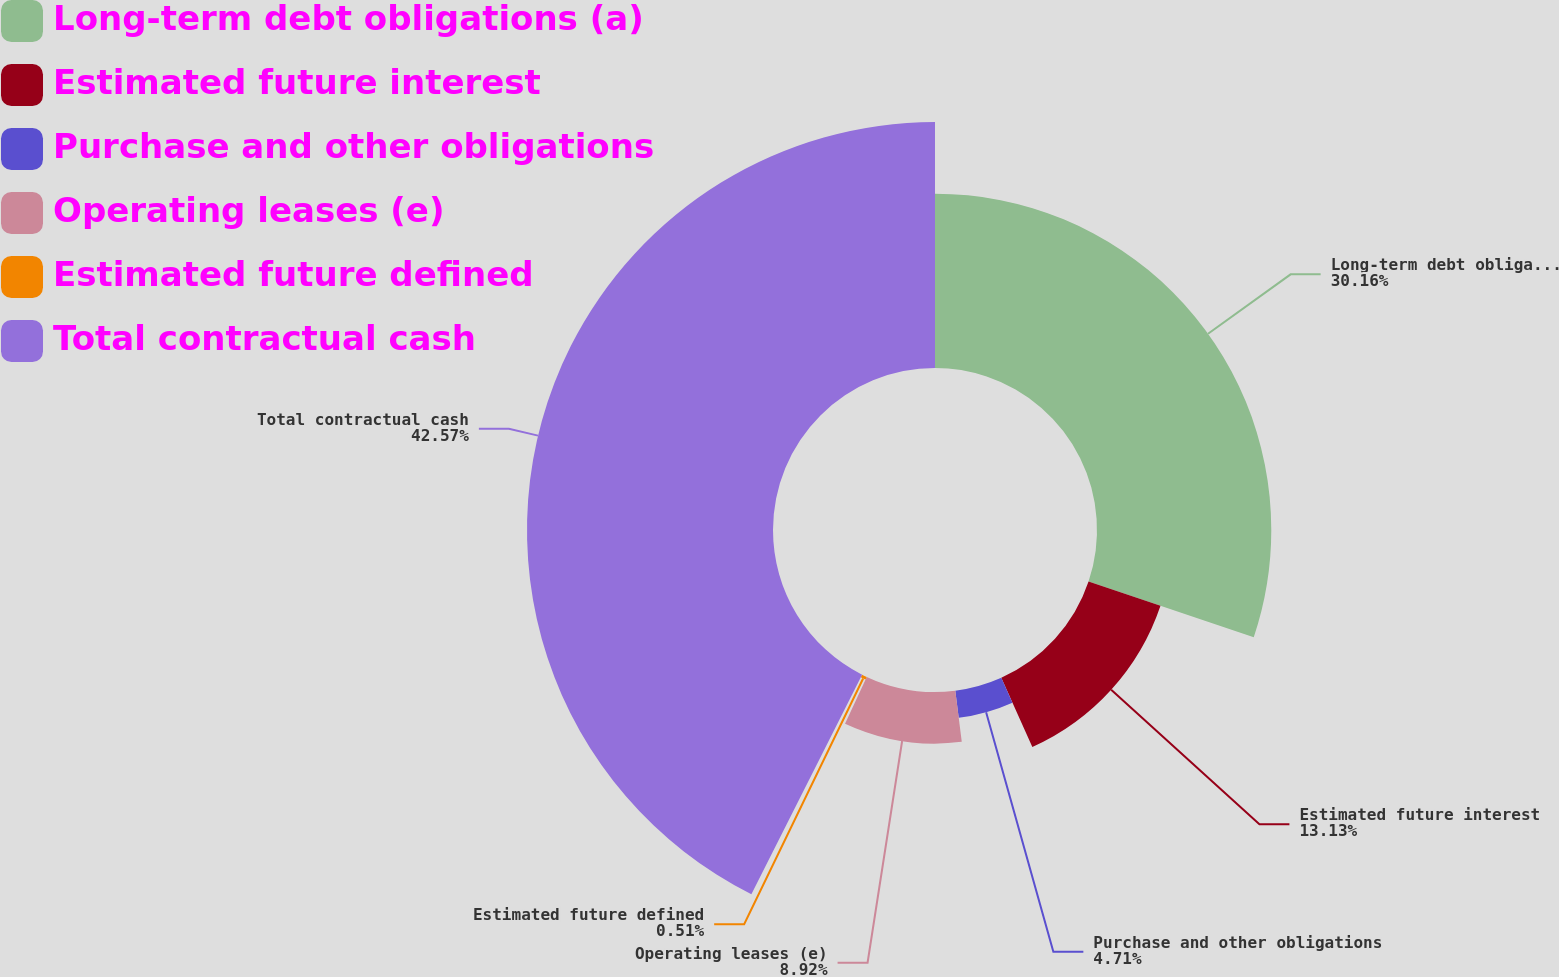Convert chart to OTSL. <chart><loc_0><loc_0><loc_500><loc_500><pie_chart><fcel>Long-term debt obligations (a)<fcel>Estimated future interest<fcel>Purchase and other obligations<fcel>Operating leases (e)<fcel>Estimated future defined<fcel>Total contractual cash<nl><fcel>30.16%<fcel>13.13%<fcel>4.71%<fcel>8.92%<fcel>0.51%<fcel>42.57%<nl></chart> 